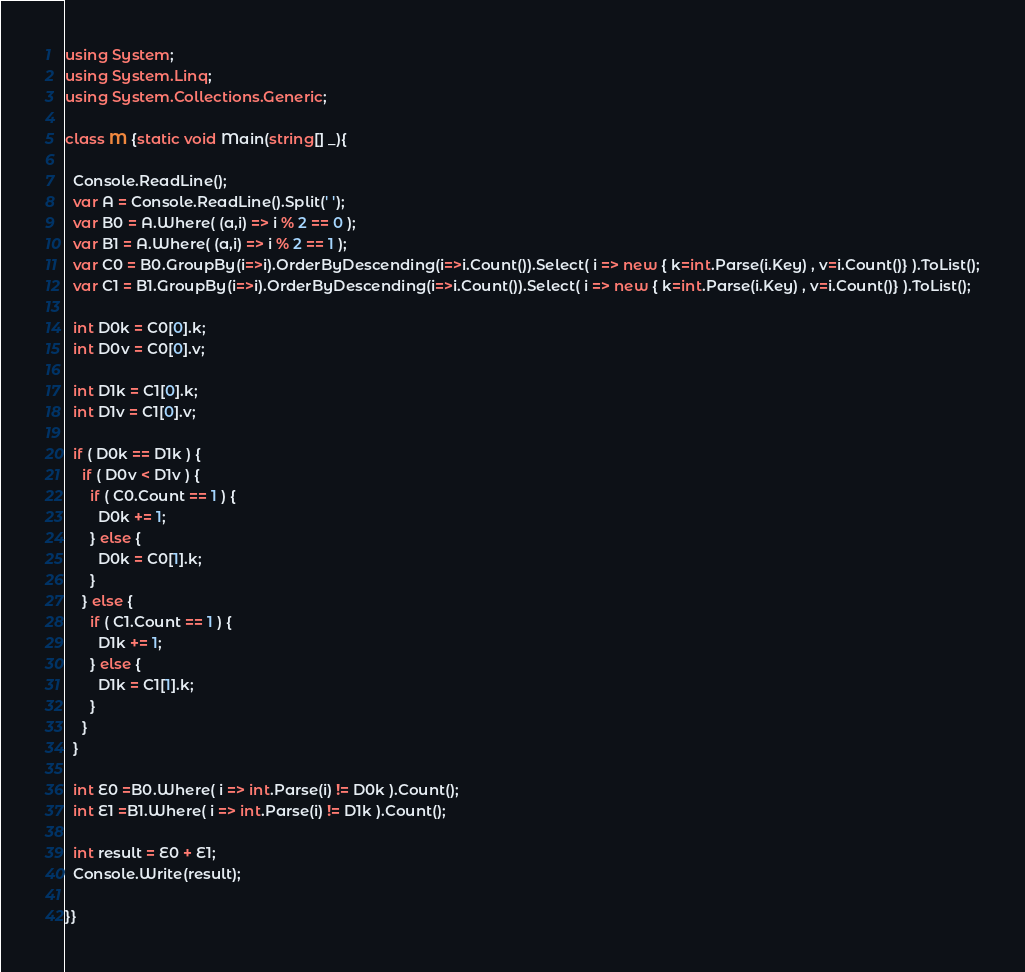Convert code to text. <code><loc_0><loc_0><loc_500><loc_500><_C#_>using System;
using System.Linq;
using System.Collections.Generic;

class M {static void Main(string[] _){
  
  Console.ReadLine();
  var A = Console.ReadLine().Split(' ');
  var B0 = A.Where( (a,i) => i % 2 == 0 );
  var B1 = A.Where( (a,i) => i % 2 == 1 );
  var C0 = B0.GroupBy(i=>i).OrderByDescending(i=>i.Count()).Select( i => new { k=int.Parse(i.Key) , v=i.Count()} ).ToList();
  var C1 = B1.GroupBy(i=>i).OrderByDescending(i=>i.Count()).Select( i => new { k=int.Parse(i.Key) , v=i.Count()} ).ToList();
  
  int D0k = C0[0].k;
  int D0v = C0[0].v;
  
  int D1k = C1[0].k;
  int D1v = C1[0].v;  
  
  if ( D0k == D1k ) {
    if ( D0v < D1v ) {
      if ( C0.Count == 1 ) {
        D0k += 1;
      } else {
	    D0k = C0[1].k;
      }
    } else {
      if ( C1.Count == 1 ) {
        D1k += 1;
      } else {
	    D1k = C1[1].k;
      }
    }
  }
  
  int E0 =B0.Where( i => int.Parse(i) != D0k ).Count();
  int E1 =B1.Where( i => int.Parse(i) != D1k ).Count();
  
  int result = E0 + E1;
  Console.Write(result);
  
}}


</code> 